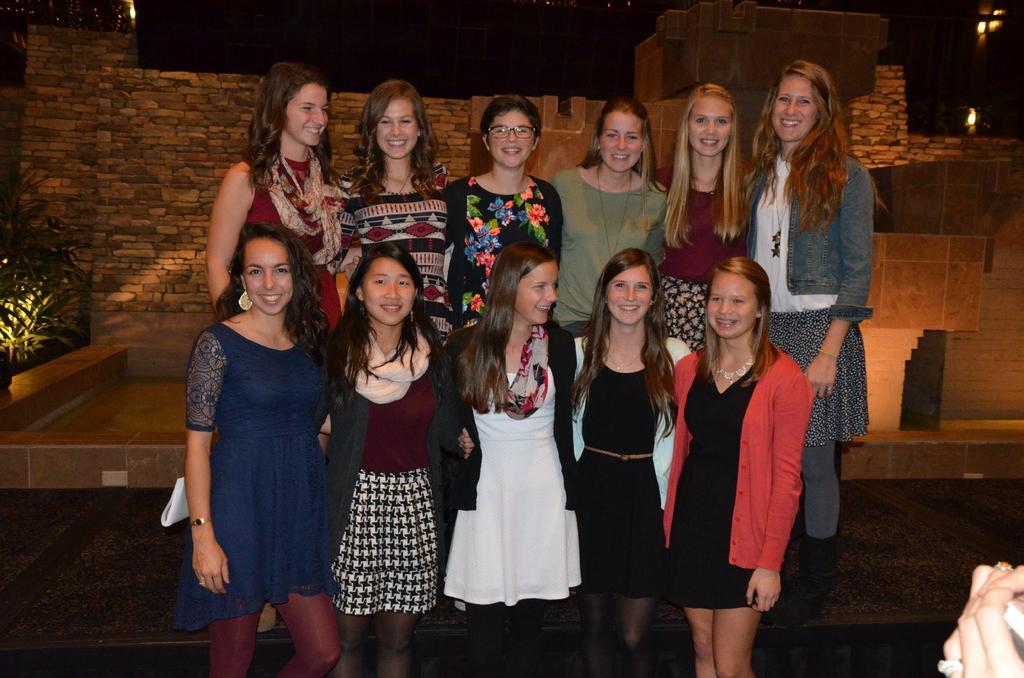Please provide a concise description of this image. In this image we can see a group of ladies are standing in two rows and taking photograph. 